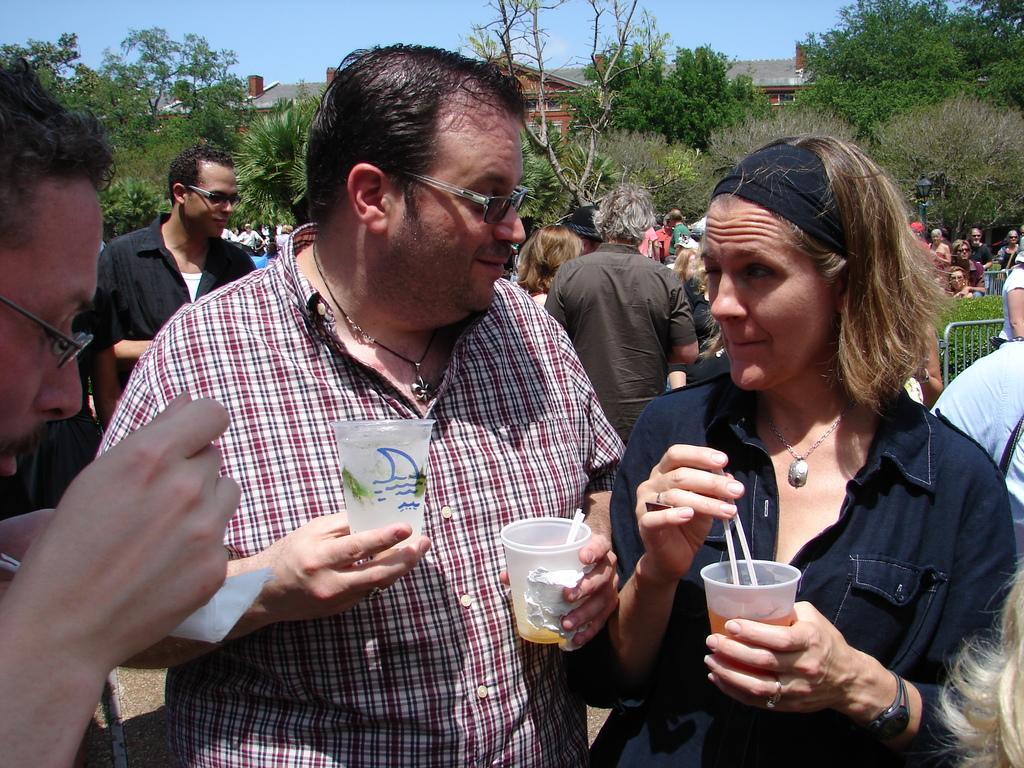In one or two sentences, can you explain what this image depicts? In this image we can see some persons, glasses and other objects. In the background of the image there are some people, trees, houses, plants and other objects. At the top of the image there is the sky. 